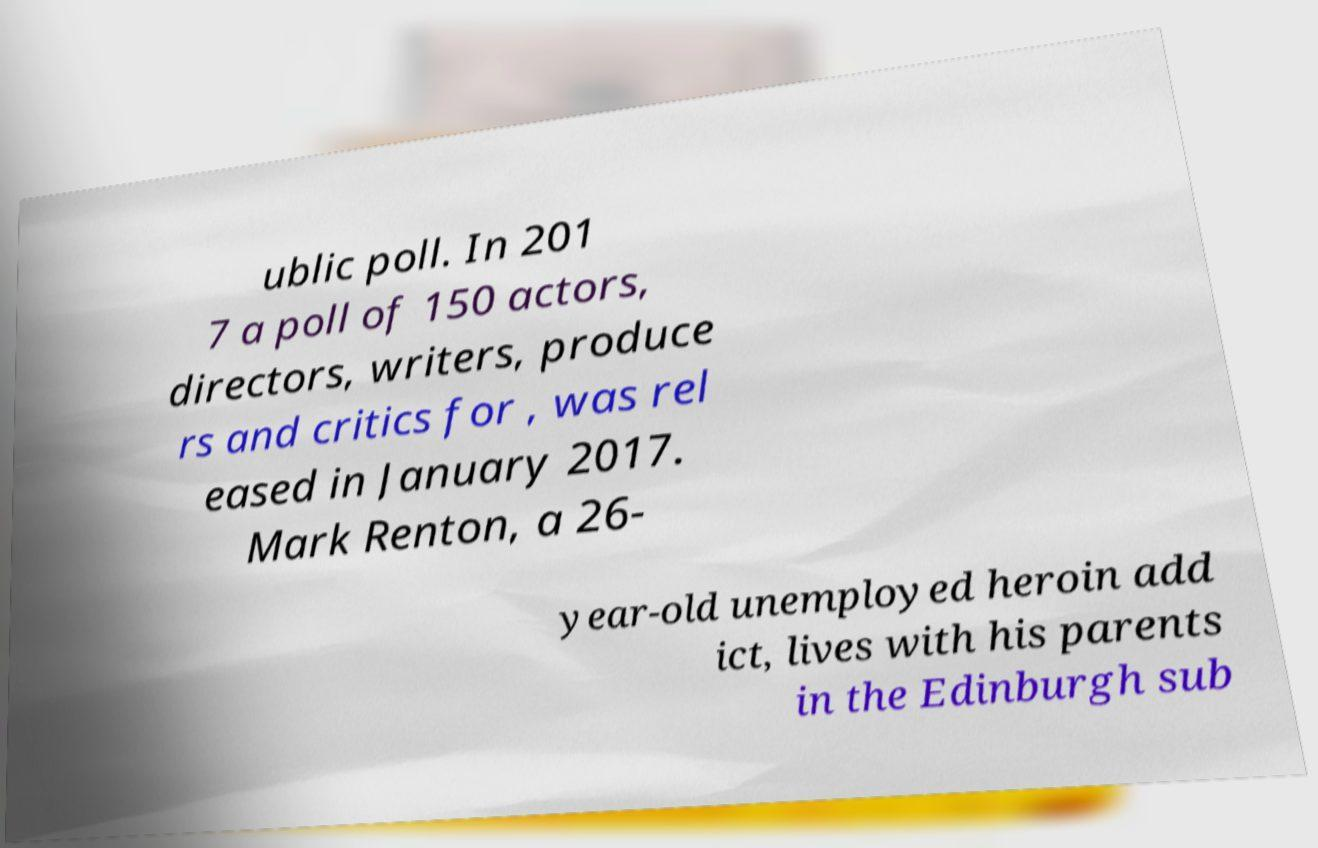I need the written content from this picture converted into text. Can you do that? ublic poll. In 201 7 a poll of 150 actors, directors, writers, produce rs and critics for , was rel eased in January 2017. Mark Renton, a 26- year-old unemployed heroin add ict, lives with his parents in the Edinburgh sub 